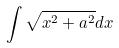Convert formula to latex. <formula><loc_0><loc_0><loc_500><loc_500>\int \sqrt { x ^ { 2 } + a ^ { 2 } } d x</formula> 